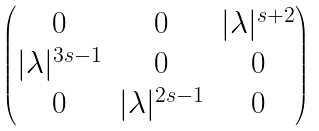<formula> <loc_0><loc_0><loc_500><loc_500>\begin{pmatrix} 0 & 0 & | \lambda | ^ { s + 2 } \\ | \lambda | ^ { 3 s - 1 } & 0 & 0 \\ 0 & | \lambda | ^ { 2 s - 1 } & 0 \end{pmatrix}</formula> 